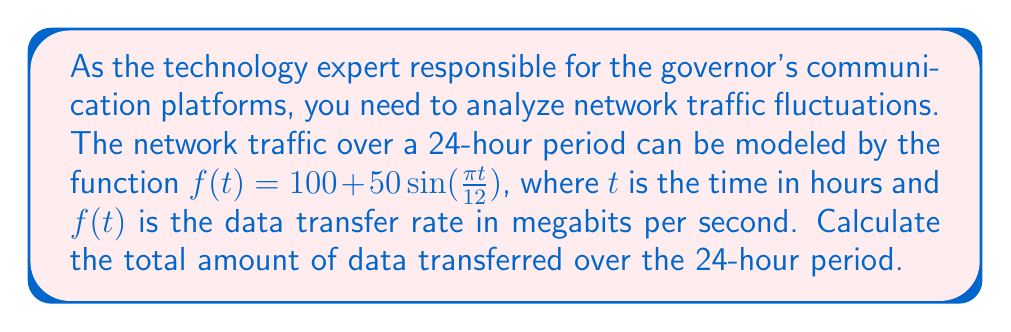Show me your answer to this math problem. To solve this problem, we need to find the area under the curve of $f(t)$ from $t=0$ to $t=24$. This can be done using a definite integral.

1. Set up the integral:
   $$\int_0^{24} (100 + 50\sin(\frac{\pi t}{12})) dt$$

2. Integrate the function:
   $$\int (100 + 50\sin(\frac{\pi t}{12})) dt = 100t - \frac{600}{\pi}\cos(\frac{\pi t}{12}) + C$$

3. Apply the limits of integration:
   $$\left[100t - \frac{600}{\pi}\cos(\frac{\pi t}{12})\right]_0^{24}$$

4. Evaluate:
   $$\left(2400 - \frac{600}{\pi}\cos(2\pi)\right) - \left(0 - \frac{600}{\pi}\cos(0)\right)$$
   $$= 2400 - \frac{600}{\pi} - 0 + \frac{600}{\pi}$$
   $$= 2400$$

5. Convert units:
   The result is in megabit-seconds. To convert to more practical units:
   $2400$ megabit-seconds $= 2400 \times 3600$ megabits $= 8,640,000$ megabits $= 8,640$ gigabits $= 8.64$ terabits
Answer: The total amount of data transferred over the 24-hour period is 8.64 terabits. 